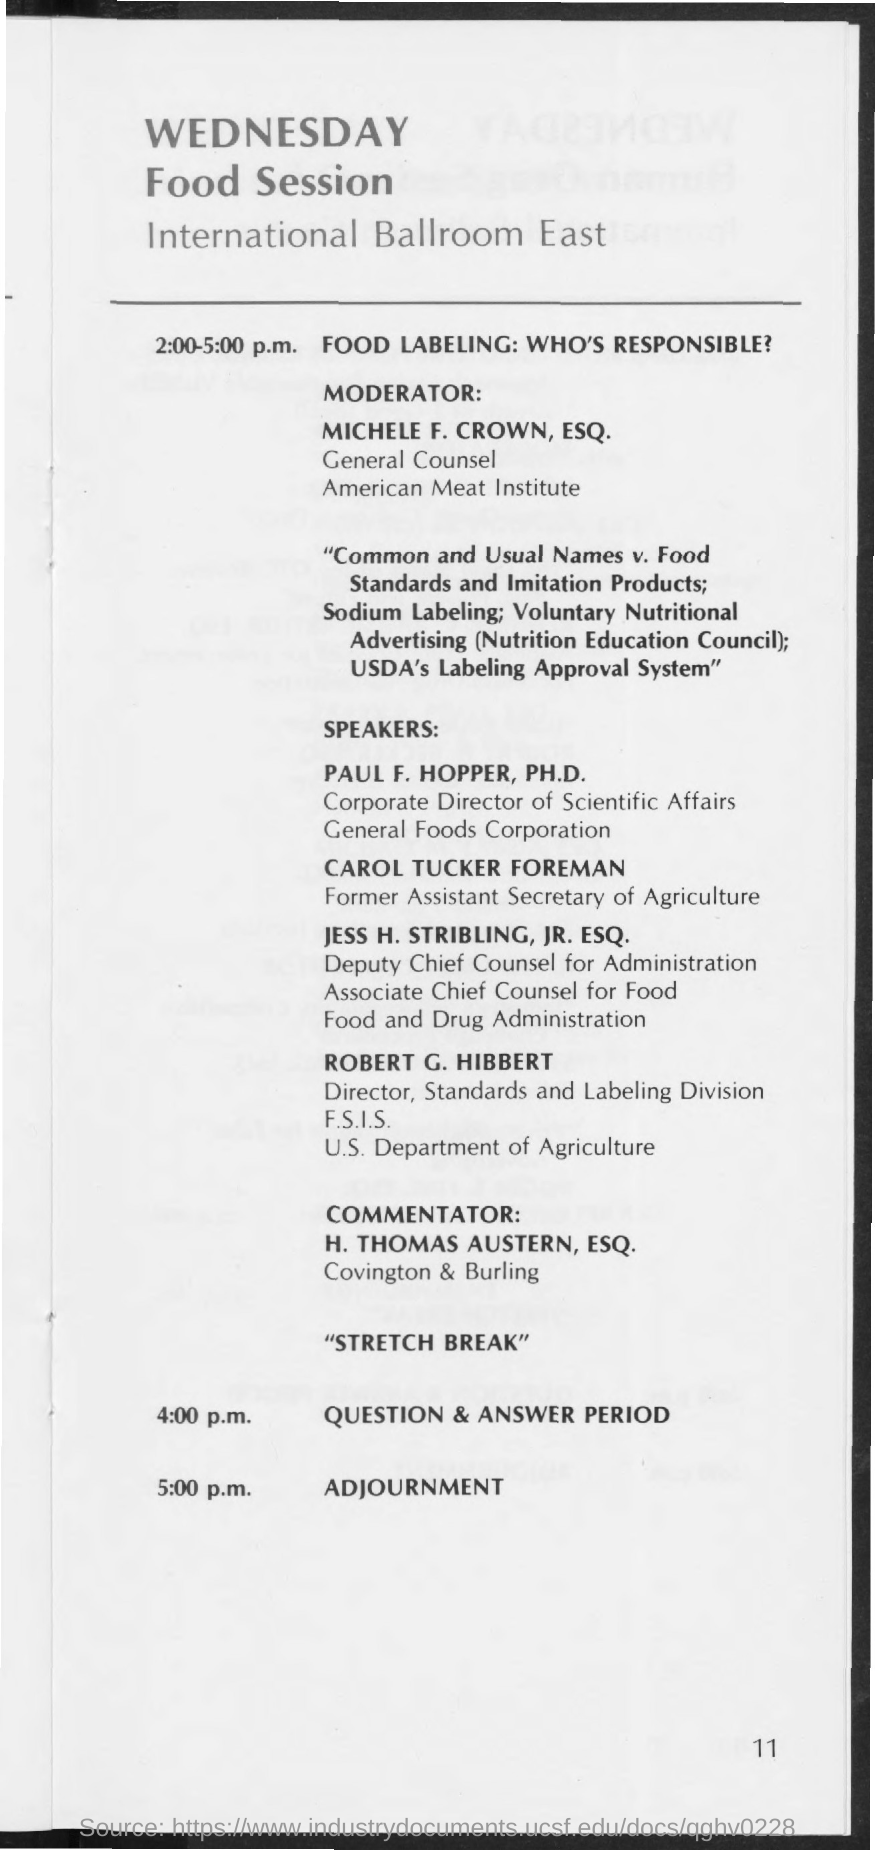Give some essential details in this illustration. The speaker is informing that the moderator is Michele F. Crown, ESQ.. The question and answer period is schedule for 4:00 p.m. 